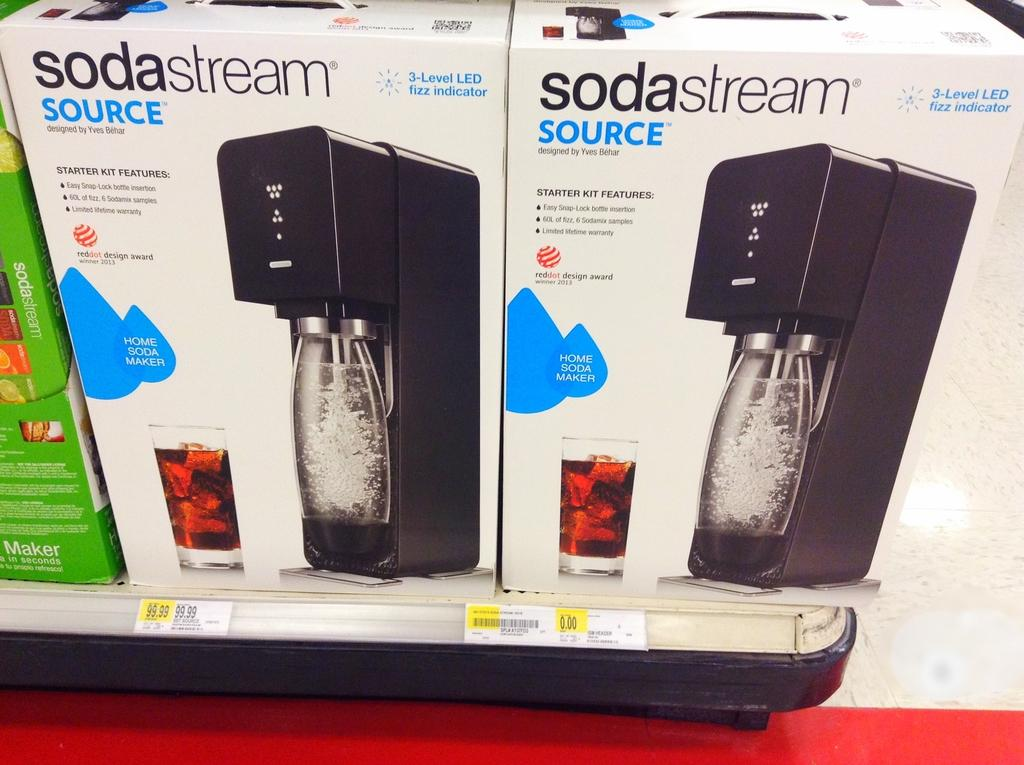<image>
Give a short and clear explanation of the subsequent image. Soda stream source that is black and in a new box 